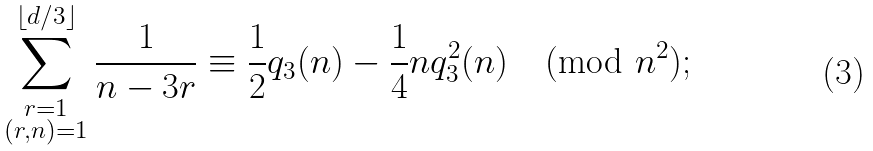Convert formula to latex. <formula><loc_0><loc_0><loc_500><loc_500>\sum _ { \substack { r = 1 \\ ( r , n ) = 1 } } ^ { \lfloor d / 3 \rfloor } \frac { 1 } { n - 3 r } \equiv \frac { 1 } { 2 } q _ { 3 } ( n ) - \frac { 1 } { 4 } n q _ { 3 } ^ { 2 } ( n ) \pmod { n ^ { 2 } } ;</formula> 